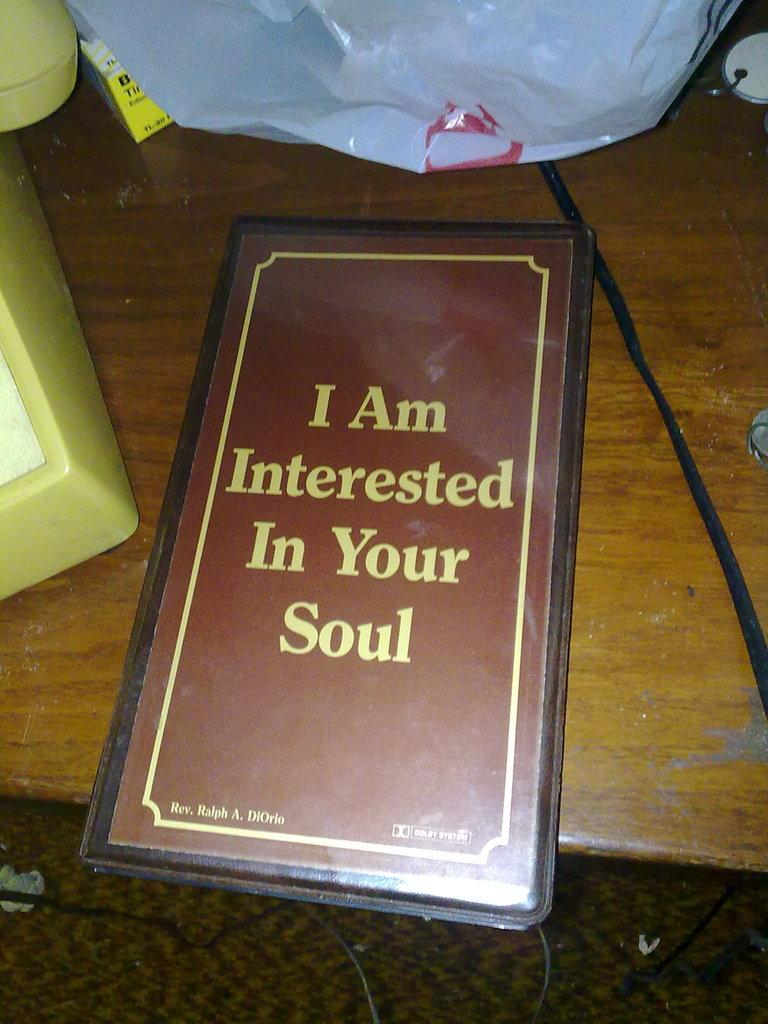<image>
Present a compact description of the photo's key features. A cover that reads "I am interested in your soul" 